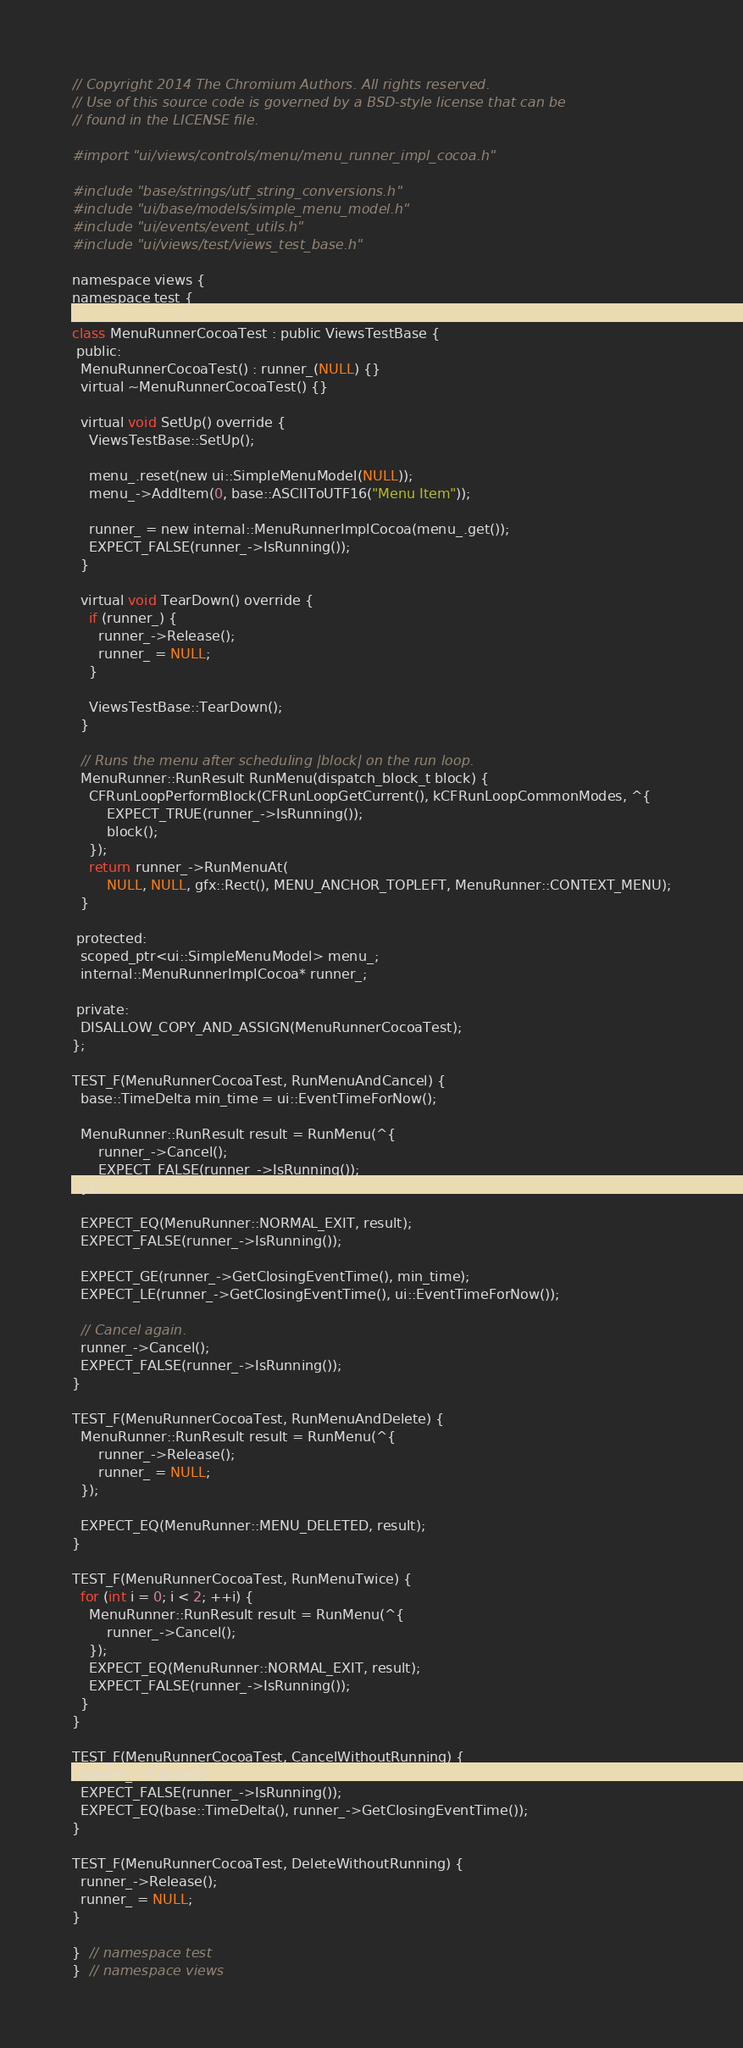Convert code to text. <code><loc_0><loc_0><loc_500><loc_500><_ObjectiveC_>// Copyright 2014 The Chromium Authors. All rights reserved.
// Use of this source code is governed by a BSD-style license that can be
// found in the LICENSE file.

#import "ui/views/controls/menu/menu_runner_impl_cocoa.h"

#include "base/strings/utf_string_conversions.h"
#include "ui/base/models/simple_menu_model.h"
#include "ui/events/event_utils.h"
#include "ui/views/test/views_test_base.h"

namespace views {
namespace test {

class MenuRunnerCocoaTest : public ViewsTestBase {
 public:
  MenuRunnerCocoaTest() : runner_(NULL) {}
  virtual ~MenuRunnerCocoaTest() {}

  virtual void SetUp() override {
    ViewsTestBase::SetUp();

    menu_.reset(new ui::SimpleMenuModel(NULL));
    menu_->AddItem(0, base::ASCIIToUTF16("Menu Item"));

    runner_ = new internal::MenuRunnerImplCocoa(menu_.get());
    EXPECT_FALSE(runner_->IsRunning());
  }

  virtual void TearDown() override {
    if (runner_) {
      runner_->Release();
      runner_ = NULL;
    }

    ViewsTestBase::TearDown();
  }

  // Runs the menu after scheduling |block| on the run loop.
  MenuRunner::RunResult RunMenu(dispatch_block_t block) {
    CFRunLoopPerformBlock(CFRunLoopGetCurrent(), kCFRunLoopCommonModes, ^{
        EXPECT_TRUE(runner_->IsRunning());
        block();
    });
    return runner_->RunMenuAt(
        NULL, NULL, gfx::Rect(), MENU_ANCHOR_TOPLEFT, MenuRunner::CONTEXT_MENU);
  }

 protected:
  scoped_ptr<ui::SimpleMenuModel> menu_;
  internal::MenuRunnerImplCocoa* runner_;

 private:
  DISALLOW_COPY_AND_ASSIGN(MenuRunnerCocoaTest);
};

TEST_F(MenuRunnerCocoaTest, RunMenuAndCancel) {
  base::TimeDelta min_time = ui::EventTimeForNow();

  MenuRunner::RunResult result = RunMenu(^{
      runner_->Cancel();
      EXPECT_FALSE(runner_->IsRunning());
  });

  EXPECT_EQ(MenuRunner::NORMAL_EXIT, result);
  EXPECT_FALSE(runner_->IsRunning());

  EXPECT_GE(runner_->GetClosingEventTime(), min_time);
  EXPECT_LE(runner_->GetClosingEventTime(), ui::EventTimeForNow());

  // Cancel again.
  runner_->Cancel();
  EXPECT_FALSE(runner_->IsRunning());
}

TEST_F(MenuRunnerCocoaTest, RunMenuAndDelete) {
  MenuRunner::RunResult result = RunMenu(^{
      runner_->Release();
      runner_ = NULL;
  });

  EXPECT_EQ(MenuRunner::MENU_DELETED, result);
}

TEST_F(MenuRunnerCocoaTest, RunMenuTwice) {
  for (int i = 0; i < 2; ++i) {
    MenuRunner::RunResult result = RunMenu(^{
        runner_->Cancel();
    });
    EXPECT_EQ(MenuRunner::NORMAL_EXIT, result);
    EXPECT_FALSE(runner_->IsRunning());
  }
}

TEST_F(MenuRunnerCocoaTest, CancelWithoutRunning) {
  runner_->Cancel();
  EXPECT_FALSE(runner_->IsRunning());
  EXPECT_EQ(base::TimeDelta(), runner_->GetClosingEventTime());
}

TEST_F(MenuRunnerCocoaTest, DeleteWithoutRunning) {
  runner_->Release();
  runner_ = NULL;
}

}  // namespace test
}  // namespace views
</code> 